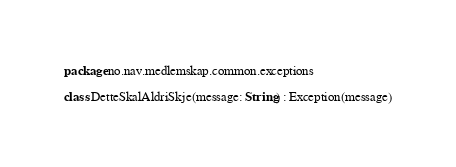Convert code to text. <code><loc_0><loc_0><loc_500><loc_500><_Kotlin_>package no.nav.medlemskap.common.exceptions

class DetteSkalAldriSkje(message: String) : Exception(message)
</code> 